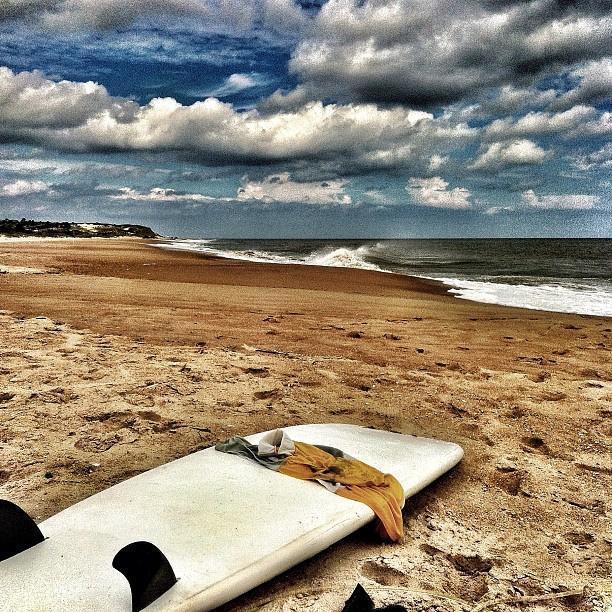How many surfboards are there?
Give a very brief answer. 1. 